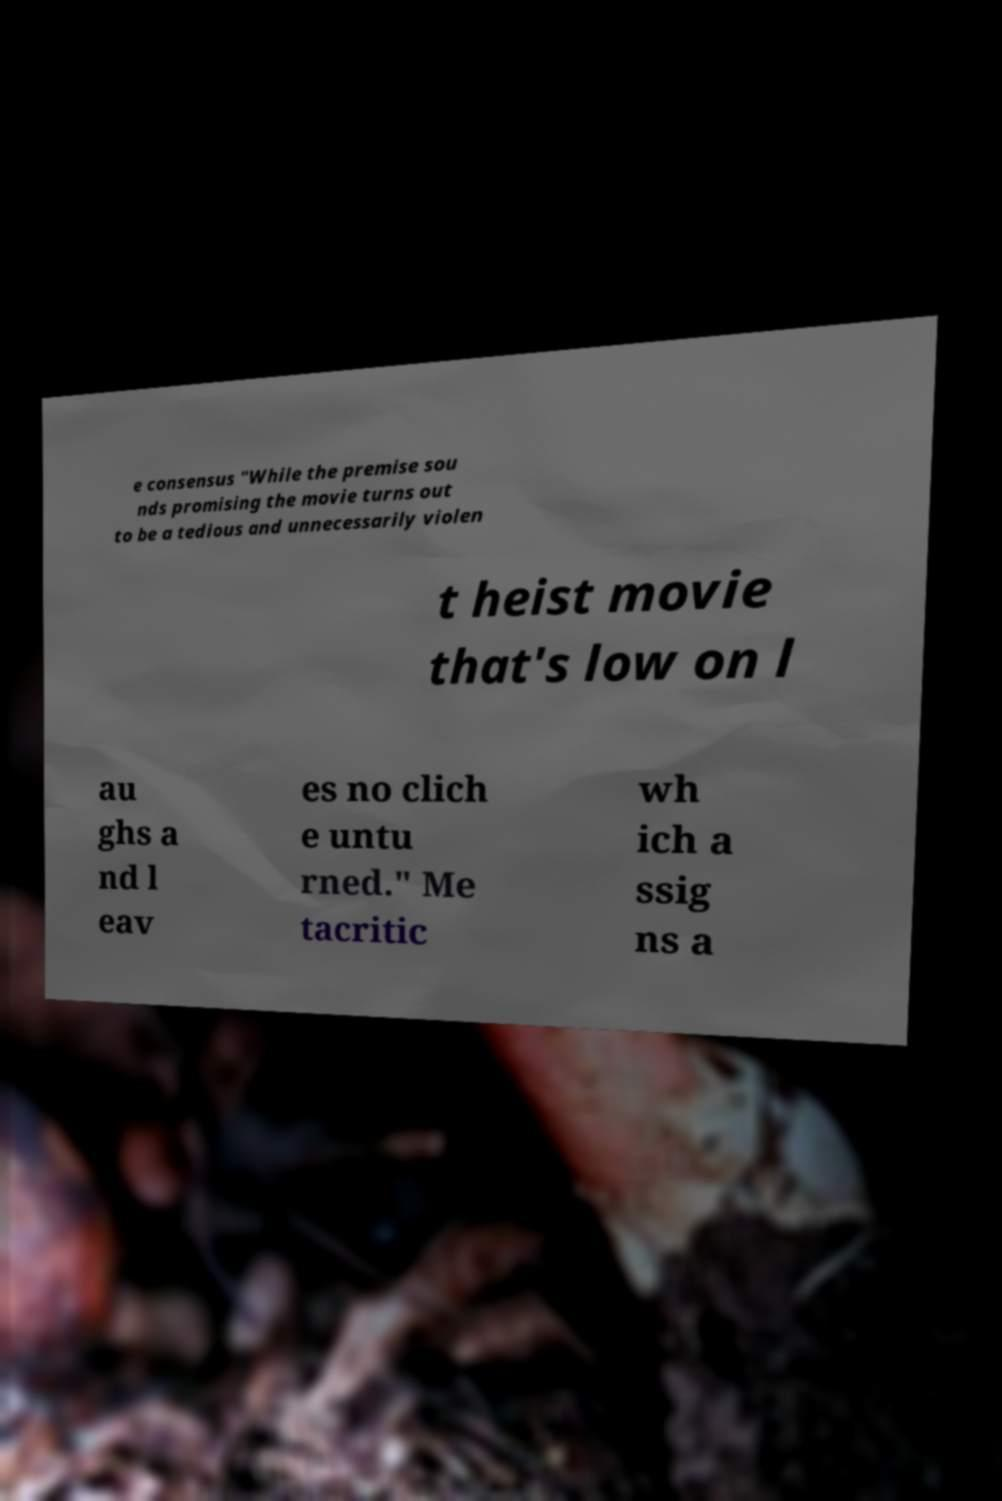Please read and relay the text visible in this image. What does it say? e consensus "While the premise sou nds promising the movie turns out to be a tedious and unnecessarily violen t heist movie that's low on l au ghs a nd l eav es no clich e untu rned." Me tacritic wh ich a ssig ns a 